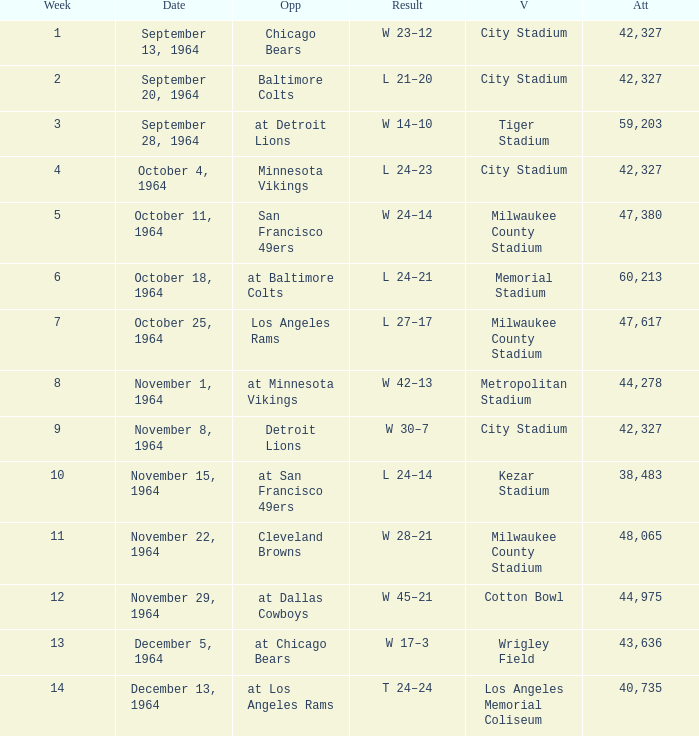What venue held that game with a result of l 24–14? Kezar Stadium. 